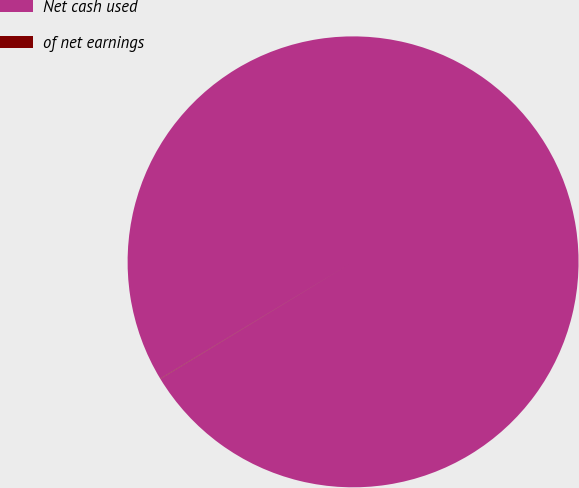<chart> <loc_0><loc_0><loc_500><loc_500><pie_chart><fcel>Net cash used<fcel>of net earnings<nl><fcel>99.98%<fcel>0.02%<nl></chart> 